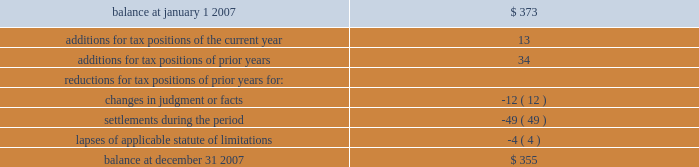United parcel service , inc .
And subsidiaries notes to consolidated financial statements 2014 ( continued ) the table summarizes the activity related to our unrecognized tax benefits ( in millions ) : .
As of december 31 , 2007 , the total amount of gross unrecognized tax benefits that , if recognized , would affect the effective tax rate was $ 134 million .
We also had gross recognized tax benefits of $ 567 million recorded as of december 31 , 2007 associated with outstanding refund claims for prior tax years .
Therefore , we had a net receivable recorded with respect to prior year income tax matters in the accompanying balance sheets .
Our continuing practice is to recognize interest and penalties associated with income tax matters as a component of income tax expense .
Related to the uncertain tax benefits noted above , we accrued penalties of $ 5 million and interest of $ 36 million during 2007 .
As of december 31 , 2007 , we have recognized a liability for penalties of $ 6 million and interest of $ 75 million .
Additionally , we have recognized a receivable for interest of $ 116 million for the recognized tax benefits associated with outstanding refund claims .
We file income tax returns in the u.s .
Federal jurisdiction , most u.s .
State and local jurisdictions , and many non-u.s .
Jurisdictions .
As of december 31 , 2007 , we had substantially resolved all u.s .
Federal income tax matters for tax years prior to 1999 .
In the third quarter of 2007 , we entered into a joint stipulation to dismiss the case with the department of justice , effectively withdrawing our refund claim related to the 1994 disposition of a subsidiary in france .
The write-off of previously recognized tax receivable balances associated with the 1994 french matter resulted in a $ 37 million increase in income tax expense for the quarter .
However , this increase was offset by the impact of favorable developments with various other u.s .
Federal , u.s .
State , and non-u.s .
Contingency matters .
In february 2008 , the irs completed its audit of the tax years 1999 through 2002 with only a limited number of issues that will be considered by the irs appeals office by 2009 .
The irs is in the final stages of completing its audit of the tax years 2003 through 2004 .
We anticipate that the irs will conclude its audit of the 2003 and 2004 tax years by 2009 .
With few exceptions , we are no longer subject to u.s .
State and local and non-u.s .
Income tax examinations by tax authorities for tax years prior to 1999 , but certain u.s .
State and local matters are subject to ongoing litigation .
A number of years may elapse before an uncertain tax position is audited and ultimately settled .
It is difficult to predict the ultimate outcome or the timing of resolution for uncertain tax positions .
It is reasonably possible that the amount of unrecognized tax benefits could significantly increase or decrease within the next twelve months .
Items that may cause changes to unrecognized tax benefits include the timing of interest deductions , the deductibility of acquisition costs , the consideration of filing requirements in various states , the allocation of income and expense between tax jurisdictions and the effects of terminating an election to have a foreign subsidiary join in filing a consolidated return .
These changes could result from the settlement of ongoing litigation , the completion of ongoing examinations , the expiration of the statute of limitations , or other unforeseen circumstances .
At this time , an estimate of the range of the reasonably possible change cannot be .
What portion of the balance of unrecognized tax benefits as of december 2017 will impact the effective tax rate? 
Computations: (134 / 355)
Answer: 0.37746. 